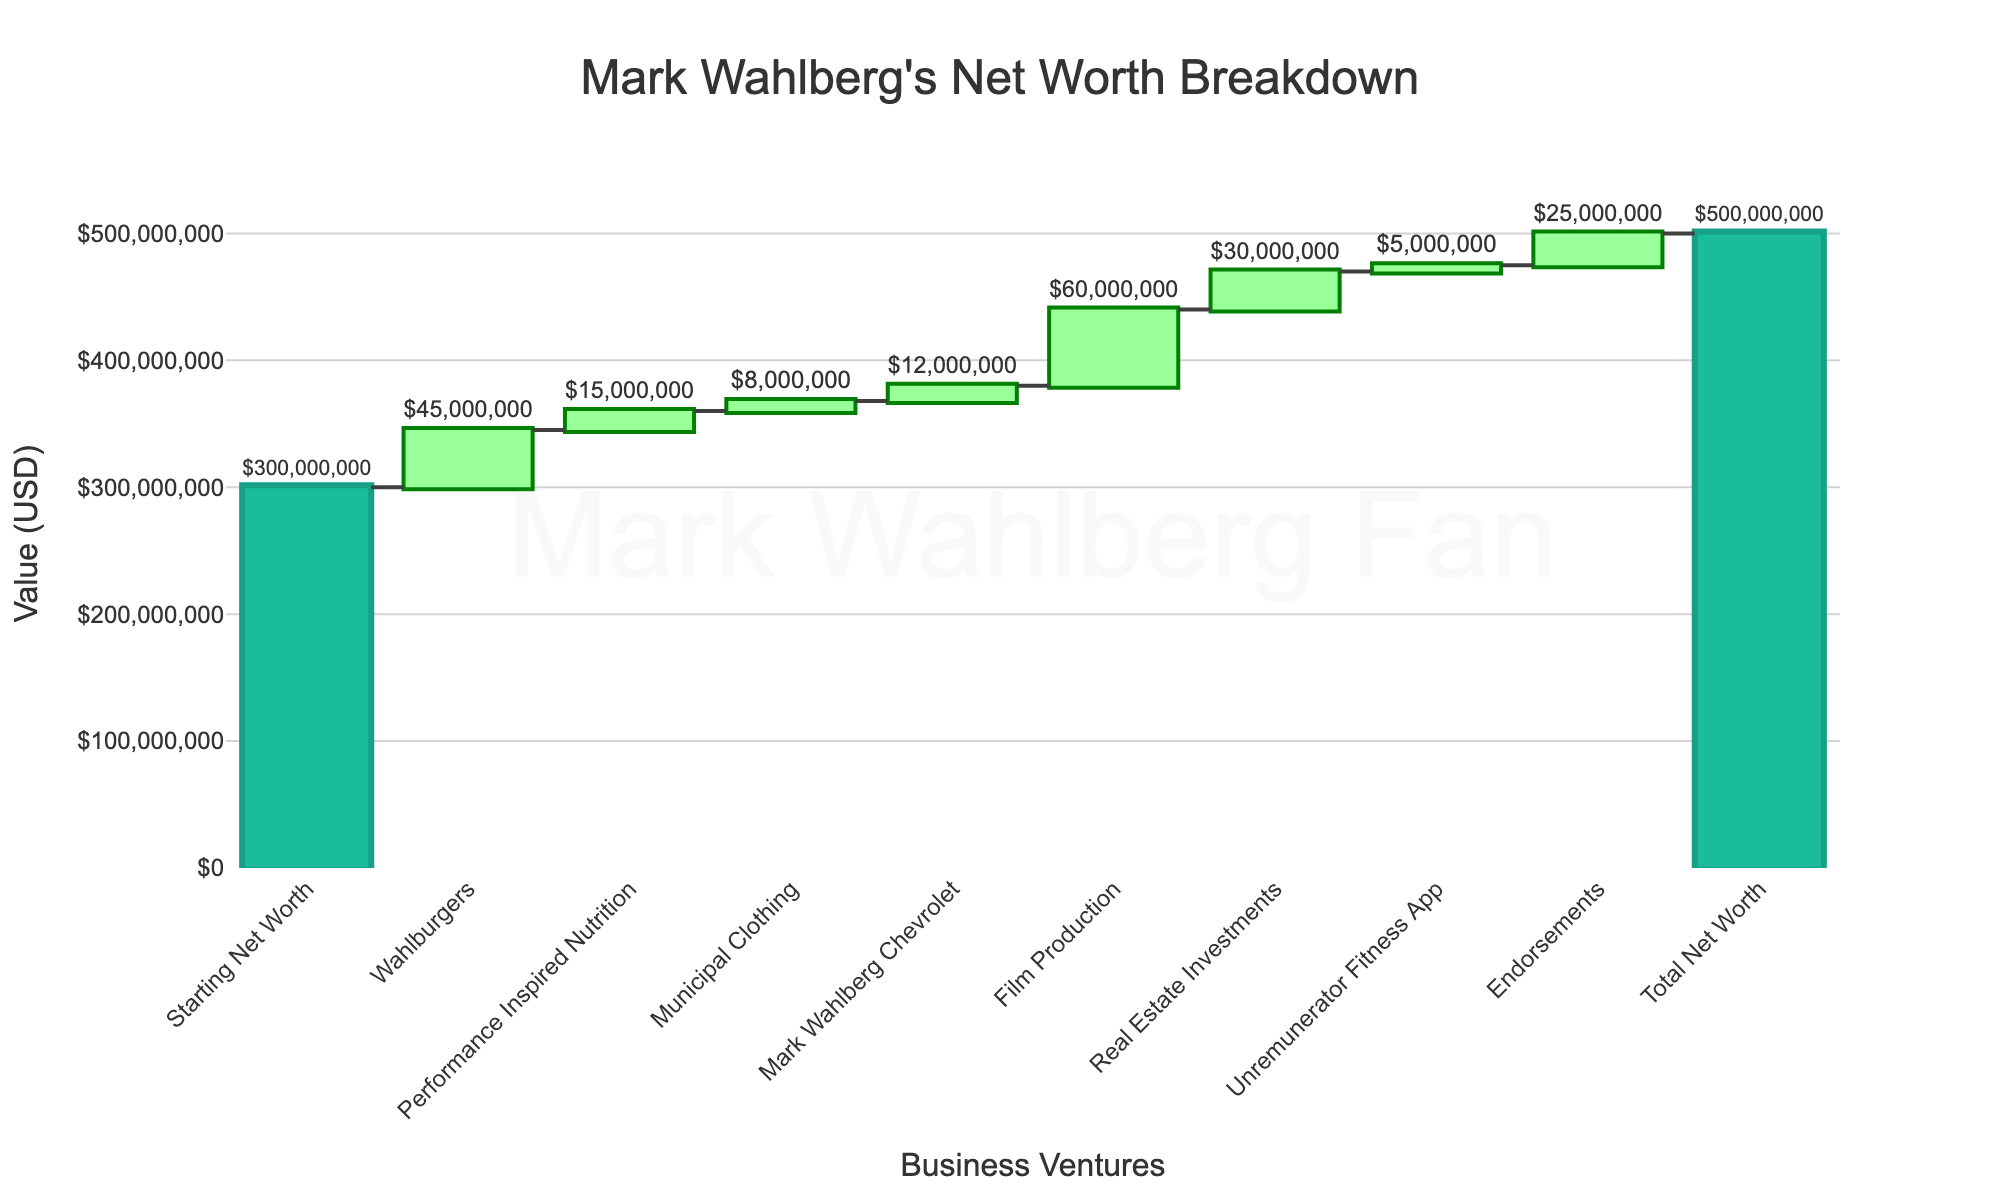How much was Mark Wahlberg's net worth before considering his business ventures? The Starting Net Worth category is shown at the beginning of the waterfall chart as an absolute value.
Answer: $300,000,000 How much did Wahlburgers contribute to Mark Wahlberg's net worth? The addition corresponding to Wahlburgers is labeled in the chart as 45,000,000.
Answer: $45,000,000 Which business venture contributed the least to Mark Wahlberg's net worth? By examining the values in the chart, Municipal Clothing has the smallest positive addition.
Answer: Municipal Clothing How much of an increase did Performance Inspired Nutrition cause in Mark Wahlberg's net worth? Performance Inspired Nutrition's addition is labeled as 15,000,000 in the chart.
Answer: $15,000,000 What is the total net worth depicted in the chart after including all business ventures and endorsements? The last bar in the chart labeled Total Net Worth shows the comprehensive aggregation of all additions.
Answer: $500,000,000 Compare the contributions of Mark Wahlberg Chevrolet and Real Estate Investments. Which one is higher and by how much? Mark Wahlberg Chevrolet contributed 12,000,000 and Real Estate Investments contributed 30,000,000. Subtract the smaller value from the larger to find the difference.
Answer: Real Estate Investments by $18,000,000 When combining the contributions from Film Production and Endorsements, what is their total cumulative value? Film Production is 60,000,000 and Endorsements is 25,000,000. Adding these two gives their total contribution.
Answer: $85,000,000 How much did Unremunerator Fitness App add to the net worth? The value corresponding to Unremunerator Fitness App in the chart is listed as 5,000,000.
Answer: $5,000,000 Which business venture among those listed contributed more than $25,000,000 to the overall worth? Examining the values, Film Production contributed 60,000,000, and Real Estate Investments contributed 30,000,000, both greater than 25,000,000.
Answer: Film Production and Real Estate Investments What is the combined contribution of all business ventures listed, excluding the Starting Net Worth and Total Net Worth categories? Sum up all contribution values: 45,000,000 (Wahlburgers) + 15,000,000 (Performance Inspired Nutrition) + 8,000,000 (Municipal Clothing) + 12,000,000 (Mark Wahlberg Chevrolet) + 60,000,000 (Film Production) + 30,000,000 (Real Estate Investments) + 5,000,000 (Unremunerator Fitness App) + 25,000,000 (Endorsements).
Answer: $200,000,000 